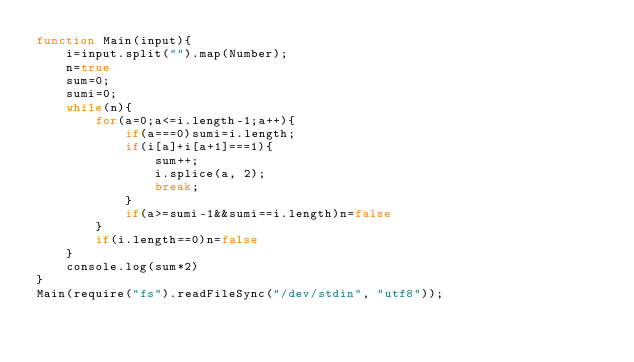Convert code to text. <code><loc_0><loc_0><loc_500><loc_500><_JavaScript_>function Main(input){
    i=input.split("").map(Number);
    n=true
    sum=0;
    sumi=0;
    while(n){
        for(a=0;a<=i.length-1;a++){
            if(a===0)sumi=i.length;
            if(i[a]+i[a+1]===1){
                sum++;
                i.splice(a, 2);
                break;
            }
            if(a>=sumi-1&&sumi==i.length)n=false
        }
        if(i.length==0)n=false
    }
    console.log(sum*2)
}
Main(require("fs").readFileSync("/dev/stdin", "utf8"));</code> 